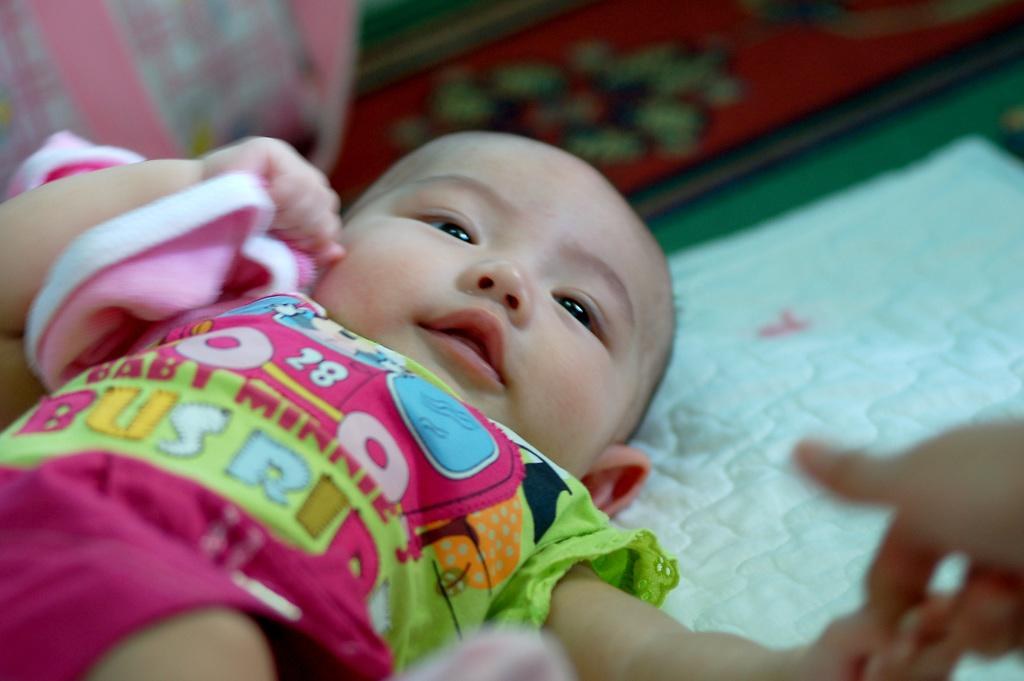What is the main subject of the image? There is a baby in the image. What is the baby lying on? The baby is lying on a green color cloth. What colors are present on the baby's dress? The baby is wearing a dress with pink, blue, and green colors. How would you describe the background of the image? The background of the image is blurred. How many cherries are on the baby's dress in the image? There are no cherries present on the baby's dress in the image. What type of sugar is used to sweeten the baby's drink in the image? There is no drink or sugar present in the image. 